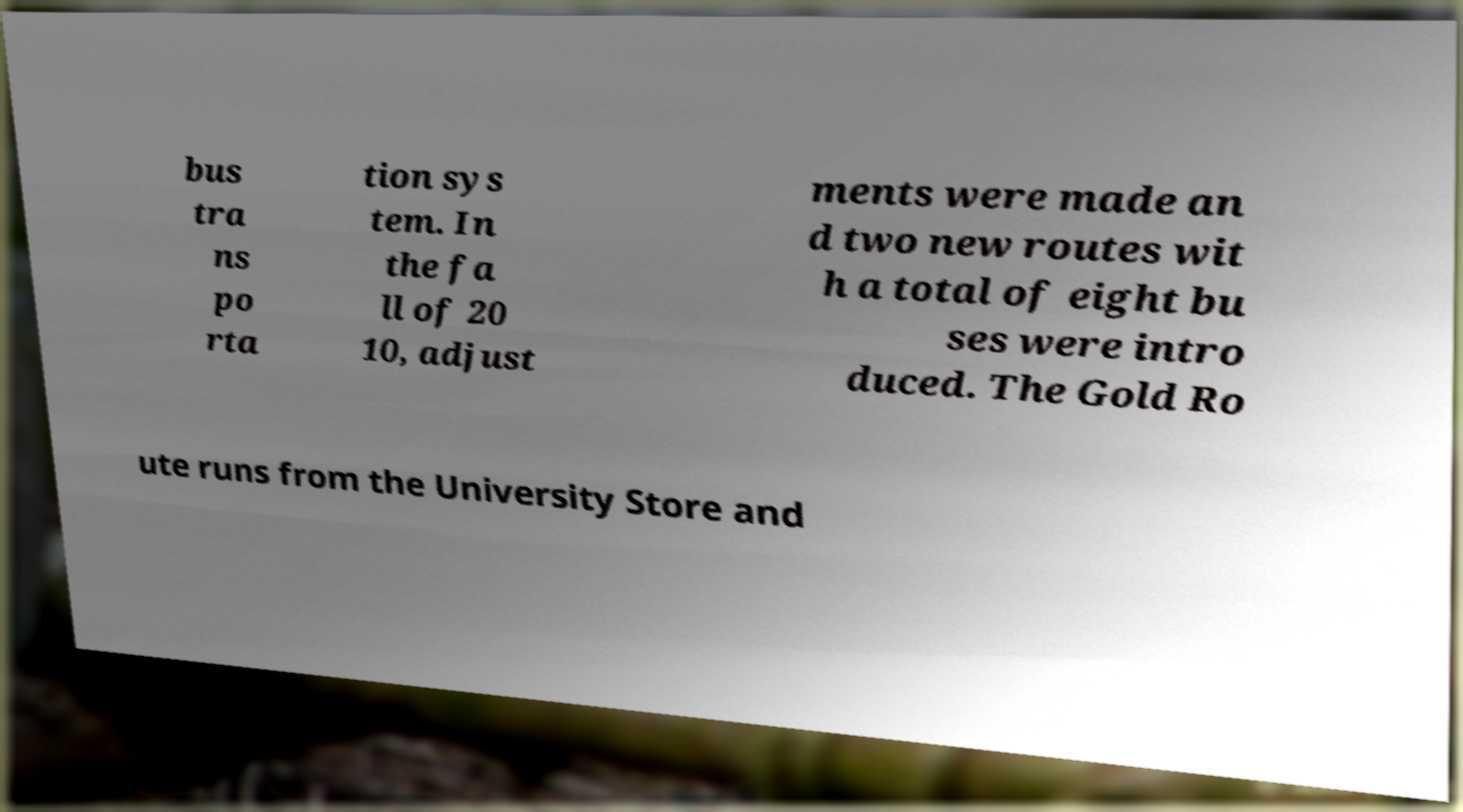Can you accurately transcribe the text from the provided image for me? bus tra ns po rta tion sys tem. In the fa ll of 20 10, adjust ments were made an d two new routes wit h a total of eight bu ses were intro duced. The Gold Ro ute runs from the University Store and 